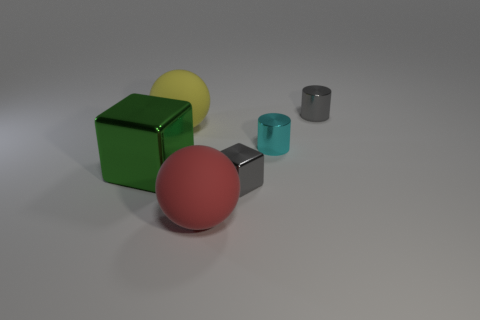What size is the metallic cylinder that is the same color as the tiny block?
Offer a terse response. Small. What number of big objects have the same color as the small cube?
Provide a short and direct response. 0. What is the size of the cyan cylinder that is made of the same material as the tiny cube?
Give a very brief answer. Small. How many things are red rubber balls or big blocks?
Your answer should be very brief. 2. There is a matte ball that is behind the large red rubber object; what is its color?
Give a very brief answer. Yellow. There is another thing that is the same shape as the large green object; what is its size?
Your answer should be compact. Small. What number of objects are cubes in front of the large metallic thing or small gray objects that are in front of the green thing?
Make the answer very short. 1. There is a metallic object that is both in front of the small cyan object and right of the yellow rubber thing; what size is it?
Make the answer very short. Small. There is a yellow thing; does it have the same shape as the gray thing behind the small cyan thing?
Provide a short and direct response. No. How many things are small gray metallic objects that are in front of the yellow thing or big purple metal things?
Your response must be concise. 1. 